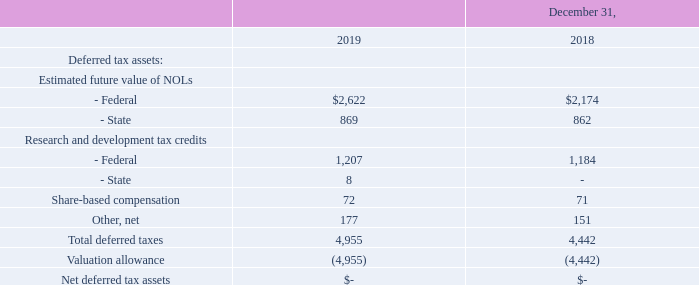Deferred Tax Assets and Valuation Allowance
Deferred tax assets reflect the tax effects of net operating losses (“NOLs”), tax credit carryovers, and temporary differences between the carrying amounts of assets and liabilities for financial reporting purposes and the amounts used for income tax purposes. The most significant item of our deferred tax assets is derived from our Federal NOLs. We have approximately $167.8 million gross Federal NOLs at December 31, 2019 (of which approximately $160.2 million was generated prior to January 1, 2018). Because we believe the ability for us to use these NOLs generated prior to January 1, 2018 to offset any future taxable income is severely limited as prescribed under Internal Revenue Code (“IRC”) Section 382, we had estimated and recorded an amount for the likely limitation to our deferred tax asset in the fourth quarter of 2017, thereby reducing the aggregate estimated benefit of the Federal NOLs available to us of approximately $1.0 million at December 31, 2017. We believe the gross Federal NOL benefit we generated prior to January 1, 2018 to offset taxable income is less than $150 thousand annually. As prescribed under Internal Revenue Code, any unused Federal NOL benefit from the annual limitation can be accumulated and carried forward to the subsequent year and will expire if not used in accordance with the NOL carried forward term of 20 years or 2037, if generated before 2018 and Federal NOLs generated after 2017 can be carried forward indefinitely. Future common stock transactions, such as the exercise of common stock purchase warrants or the conversion of debt into common stock, may cause another qualifying event under IRC 382 which may further limit our utilization of our NOLs.
The components of our deferred tax assets are as follows (in thousands):
The realization of deferred income tax assets is dependent upon future earnings, if any, and the timing and amount of which may be uncertain. A valuation allowance is required against deferred income tax assets if, based on the weight of available evidence, it is more likely than not that some or all of the deferred income tax assets may not be realized. At both December 31, 2019 and 2018, all our remaining net deferred income tax assets were offset by a valuation allowance due to uncertainties with respect to future utilization of NOL carryforwards. If in the future it is determined that additional amounts of our deferred income tax assets would likely be realized, the valuation allowance would be reduced in the period in which such determination is made and an additional benefit from income taxes in such period would be recognized.
What is the most significant item of the deferred tax assets? The most significant item of our deferred tax assets is derived from our federal nols. What happens to unused Federal NOL benefit according to Internal Revenue Code? As prescribed under internal revenue code, any unused federal nol benefit from the annual limitation can be accumulated and carried forward to the subsequent year and will expire if not used in accordance with the nol carried forward term of 20 years or 2037, if generated before 2018 and federal nols generated after 2017 can be carried forward indefinitely. Why are deferred income tax assets offset in 2018 and 2019? At both december 31, 2019 and 2018, all our remaining net deferred income tax assets were offset by a valuation allowance due to uncertainties with respect to future utilization of nol carryforwards. What is the difference between the total deferred tax in 2018 and 2019?
Answer scale should be: thousand. 4,955 - 4,442 
Answer: 513. How much did R&D tax credits from the Federal increased from 2018 to 2019?
Answer scale should be: thousand. 1,207 - 1,184 
Answer: 23. What is the increase in Net deferred tax assets from 2018 to 2019?
Answer scale should be: thousand. 0 - 0 
Answer: 0. 